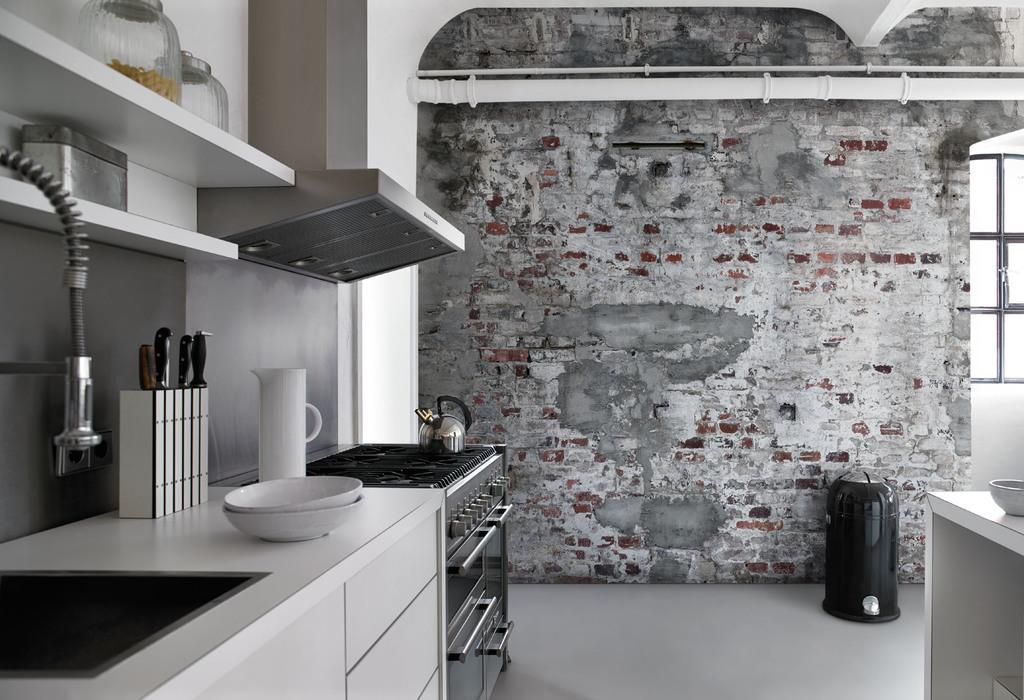How would you summarize this image in a sentence or two? In this image on the left side there are bowls, there is a jar and there is a tap. There are shelves, on the shelfs there are jars and there is an object which is silver in colour. In the center there is a wall and in front of the wall there is an object which is black in colour. On the right side there is a window and there is a table. On the table there is a bowl which is white in colour. On the left side there is a stove, on the stove there is a kettle. 